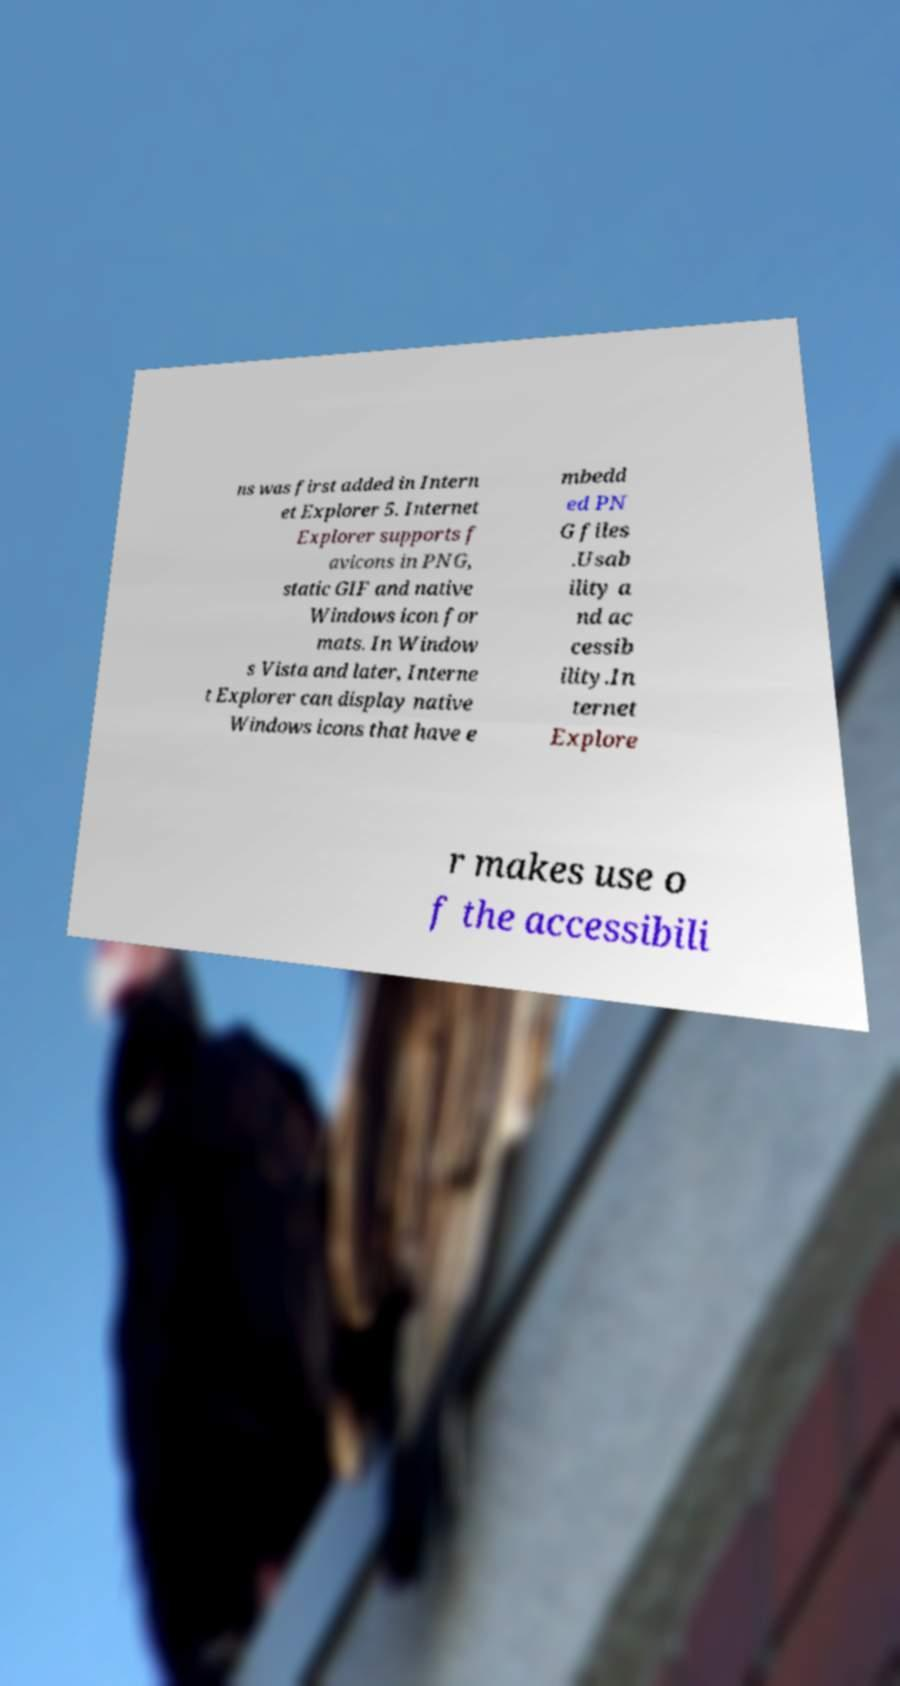Can you accurately transcribe the text from the provided image for me? ns was first added in Intern et Explorer 5. Internet Explorer supports f avicons in PNG, static GIF and native Windows icon for mats. In Window s Vista and later, Interne t Explorer can display native Windows icons that have e mbedd ed PN G files .Usab ility a nd ac cessib ility.In ternet Explore r makes use o f the accessibili 